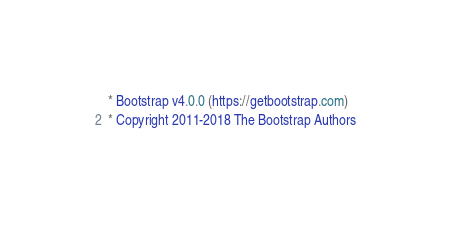<code> <loc_0><loc_0><loc_500><loc_500><_CSS_> * Bootstrap v4.0.0 (https://getbootstrap.com)
 * Copyright 2011-2018 The Bootstrap Authors</code> 